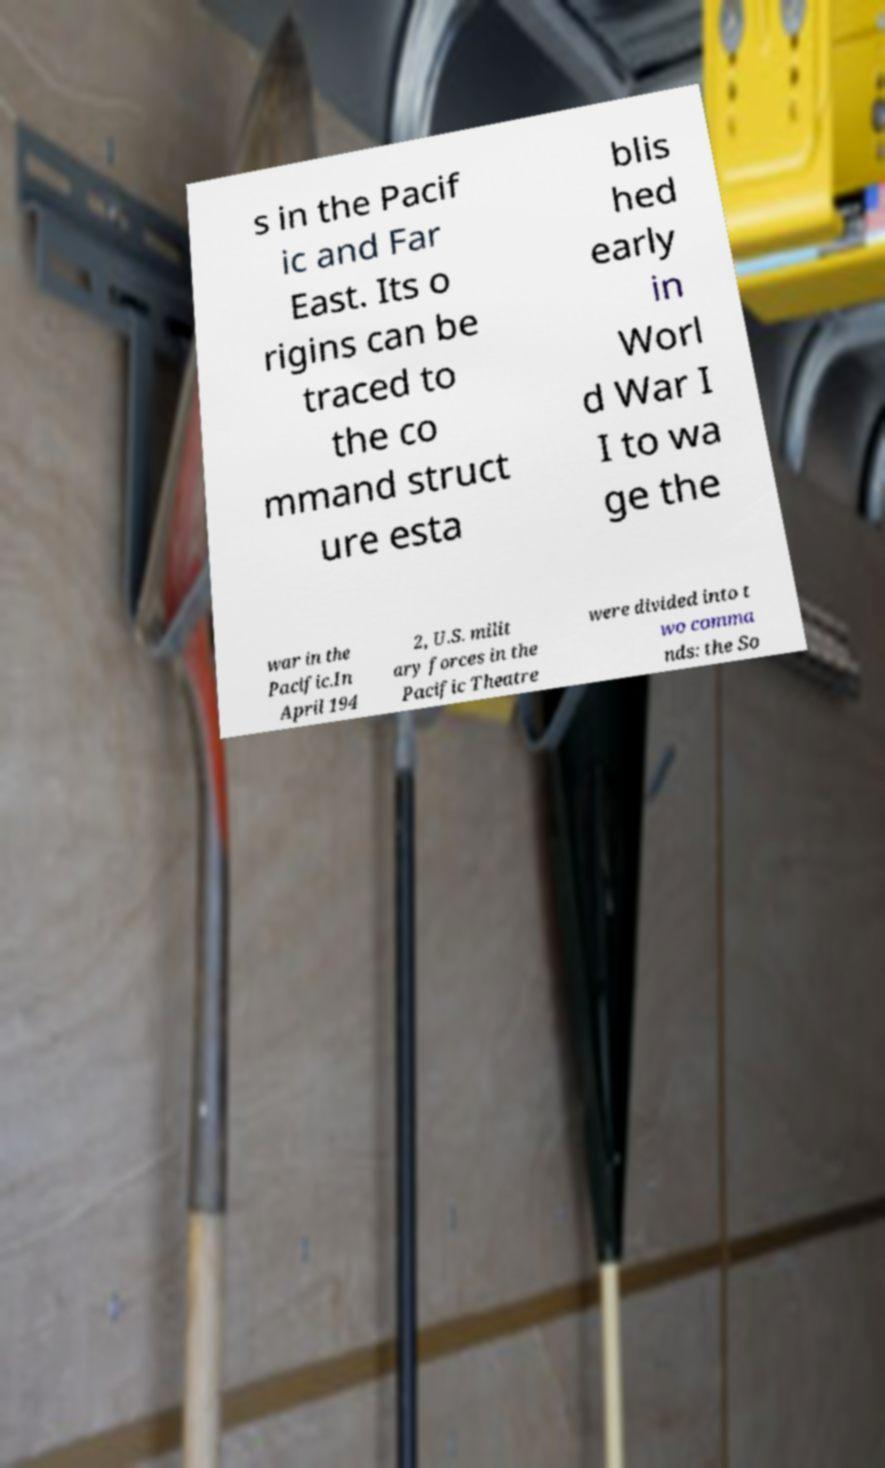Could you extract and type out the text from this image? s in the Pacif ic and Far East. Its o rigins can be traced to the co mmand struct ure esta blis hed early in Worl d War I I to wa ge the war in the Pacific.In April 194 2, U.S. milit ary forces in the Pacific Theatre were divided into t wo comma nds: the So 